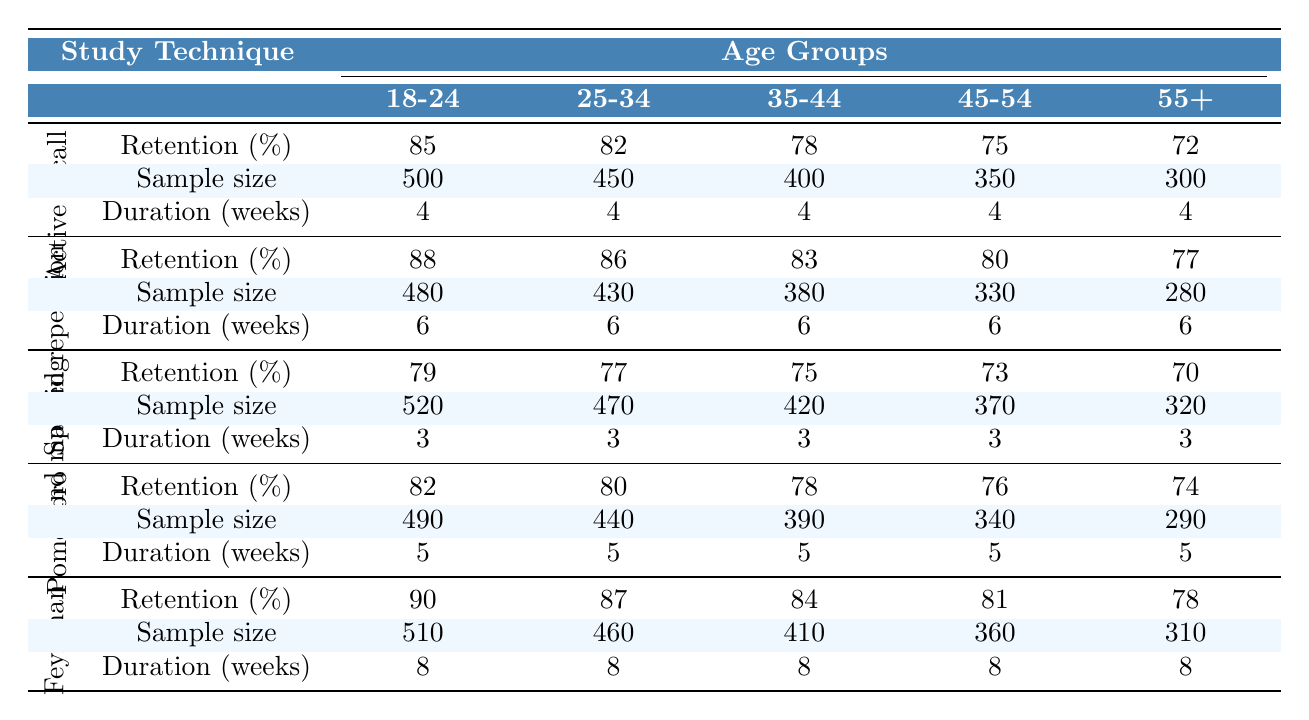What is the retention rate for the Feynman technique in the 25-34 age group? Looking at the row for the Feynman technique and the column for the 25-34 age group, the retention rate is 87%.
Answer: 87% Which study technique has the highest retention rate among the 55+ age group? Reviewing the retention rates for the 55+ age group, the Feynman technique has the highest retention rate of 78%.
Answer: Feynman technique What is the average retention rate across all age groups for the Spaced repetition technique? The retention rates for the Spaced repetition technique across the age groups are 88, 86, 83, 80, and 77. Adding these gives 414, and dividing by 5 results in an average retention rate of 82.8%.
Answer: 82.8% Is the sample size for the 35-44 age group larger for Active recall compared to Mind mapping? The sample size for the 35-44 age group is 400 for Active recall and 420 for Mind mapping. Therefore, the sample size for Mind mapping is larger.
Answer: No What is the total sample size for all age groups using the Pomodoro technique? The sample sizes for the Pomodoro technique across the age groups are 490, 440, 390, 340, and 290. Summing these gives 1990.
Answer: 1990 Which technique has the lowest retention rate in the 18-24 age group? Among all techniques in the 18-24 age group, the Mind mapping technique has the lowest retention rate of 79%.
Answer: Mind mapping What is the retention rate difference between the Spaced repetition and Pomodoro techniques for the 45-54 age group? The retention rates are 80% for Spaced repetition and 76% for Pomodoro in the 45-54 age group. The difference is 80 - 76 = 4%.
Answer: 4% Which age group shows the least variability in retention rates across the different study techniques? By assessing the retention rates for each age group, the 55+ age group has scores of 78, 77, 84, 81, and 90, which gives a range of 12. In comparison, the other age groups have larger ranges. Therefore, the 55+ age group shows the least variability.
Answer: 55+ How does the study duration of the Feynman technique compare to the other techniques in terms of weeks? The Feynman technique has a duration of 8 weeks. Comparing with the other techniques, Active recall (4 weeks), Spaced repetition (6 weeks), Mind mapping (3 weeks), and Pomodoro (5 weeks) are all shorter.
Answer: Longer What is the retention percentage for Active recall in the age group 45-54? For the Active recall technique, the retention percentage for the age group 45-54 is 75%.
Answer: 75% 